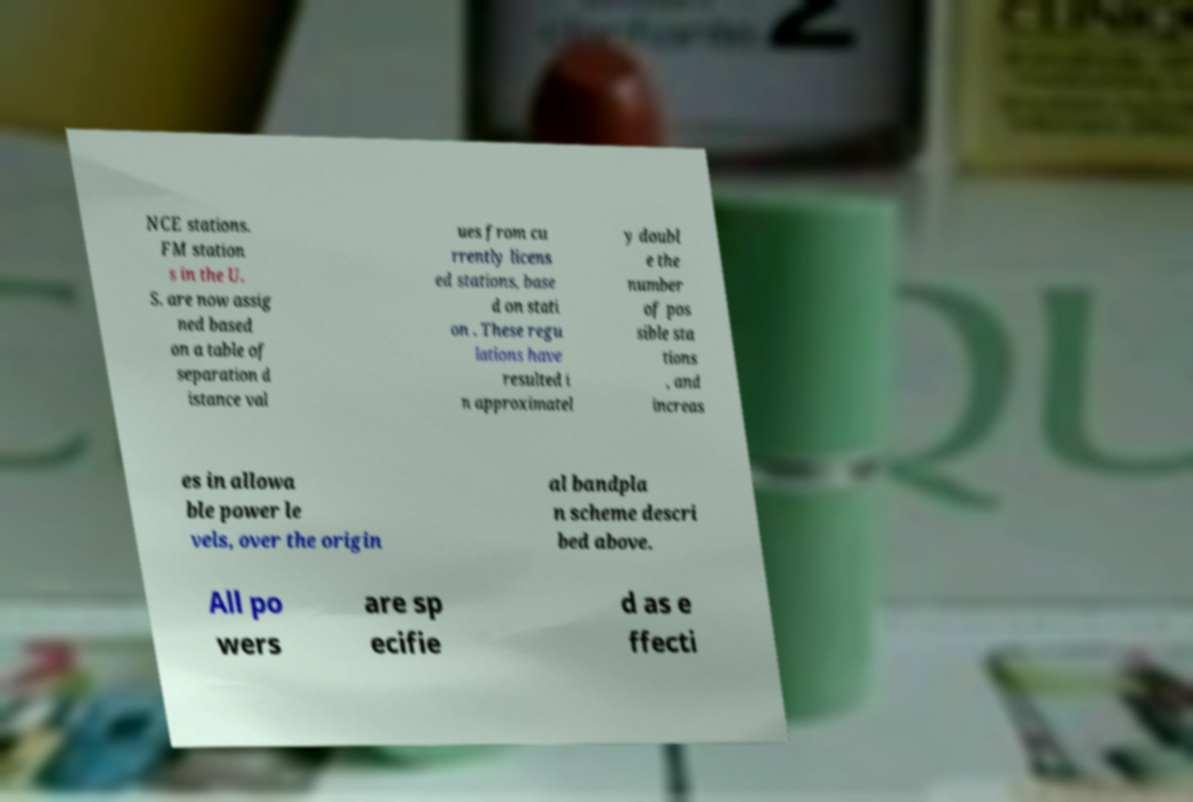Can you read and provide the text displayed in the image?This photo seems to have some interesting text. Can you extract and type it out for me? NCE stations. FM station s in the U. S. are now assig ned based on a table of separation d istance val ues from cu rrently licens ed stations, base d on stati on . These regu lations have resulted i n approximatel y doubl e the number of pos sible sta tions , and increas es in allowa ble power le vels, over the origin al bandpla n scheme descri bed above. All po wers are sp ecifie d as e ffecti 